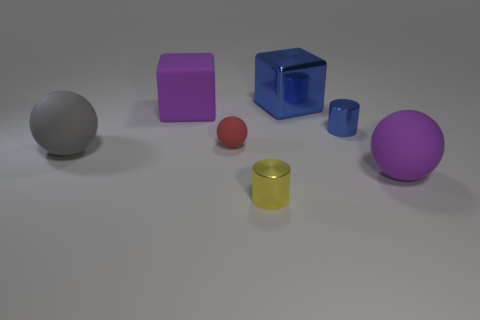The cylinder that is the same color as the big shiny block is what size?
Give a very brief answer. Small. What number of other objects are there of the same size as the shiny block?
Make the answer very short. 3. How many big purple matte balls are there?
Provide a short and direct response. 1. Do the gray object and the red matte object have the same size?
Provide a short and direct response. No. What number of other objects are the same shape as the gray rubber thing?
Make the answer very short. 2. There is a large purple object that is right of the small object that is to the right of the small yellow shiny thing; what is it made of?
Your answer should be very brief. Rubber. There is a purple ball; are there any small red spheres in front of it?
Ensure brevity in your answer.  No. There is a red rubber sphere; is it the same size as the blue block behind the red ball?
Give a very brief answer. No. There is another object that is the same shape as the yellow shiny object; what size is it?
Your answer should be compact. Small. Is there any other thing that has the same material as the tiny blue cylinder?
Your response must be concise. Yes. 